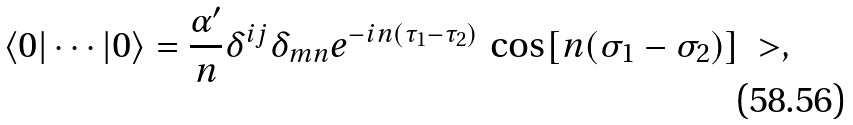Convert formula to latex. <formula><loc_0><loc_0><loc_500><loc_500>\langle 0 | \cdots | 0 \rangle = \frac { \alpha ^ { \prime } } { n } \delta ^ { i j } \delta _ { m n } e ^ { - i n ( \tau _ { 1 } - \tau _ { 2 } ) } \, \cos [ n ( \sigma _ { 1 } - \sigma _ { 2 } ) ] \ > ,</formula> 